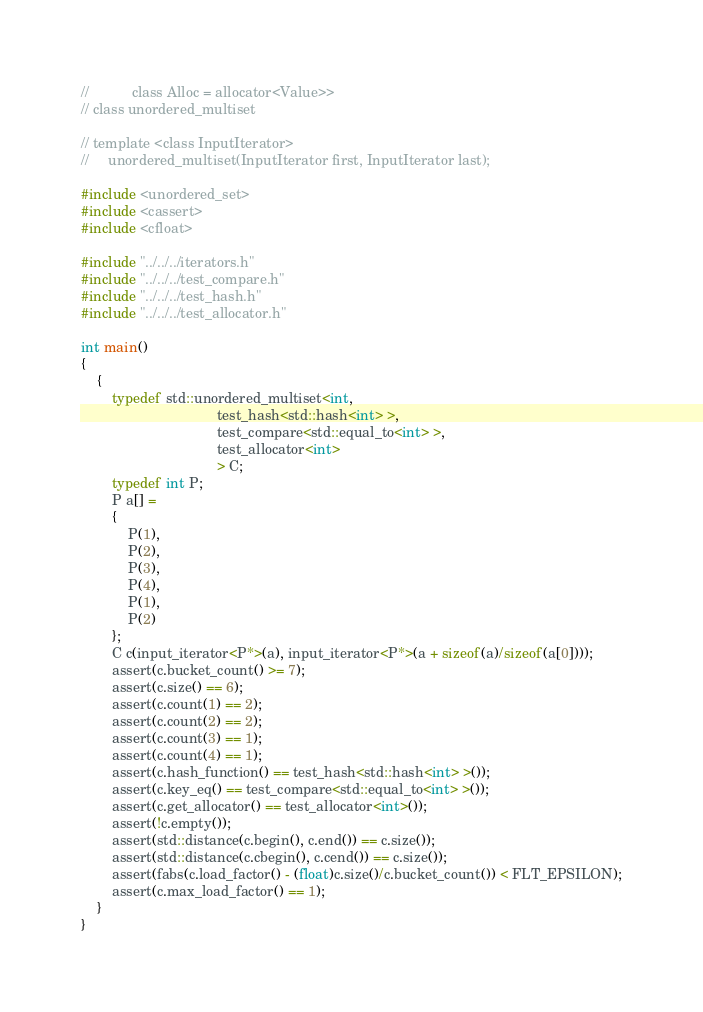Convert code to text. <code><loc_0><loc_0><loc_500><loc_500><_C++_>//           class Alloc = allocator<Value>>
// class unordered_multiset

// template <class InputIterator>
//     unordered_multiset(InputIterator first, InputIterator last);

#include <unordered_set>
#include <cassert>
#include <cfloat>

#include "../../../iterators.h"
#include "../../../test_compare.h"
#include "../../../test_hash.h"
#include "../../../test_allocator.h"

int main()
{
    {
        typedef std::unordered_multiset<int,
                                   test_hash<std::hash<int> >,
                                   test_compare<std::equal_to<int> >,
                                   test_allocator<int>
                                   > C;
        typedef int P;
        P a[] =
        {
            P(1),
            P(2),
            P(3),
            P(4),
            P(1),
            P(2)
        };
        C c(input_iterator<P*>(a), input_iterator<P*>(a + sizeof(a)/sizeof(a[0])));
        assert(c.bucket_count() >= 7);
        assert(c.size() == 6);
        assert(c.count(1) == 2);
        assert(c.count(2) == 2);
        assert(c.count(3) == 1);
        assert(c.count(4) == 1);
        assert(c.hash_function() == test_hash<std::hash<int> >());
        assert(c.key_eq() == test_compare<std::equal_to<int> >());
        assert(c.get_allocator() == test_allocator<int>());
        assert(!c.empty());
        assert(std::distance(c.begin(), c.end()) == c.size());
        assert(std::distance(c.cbegin(), c.cend()) == c.size());
        assert(fabs(c.load_factor() - (float)c.size()/c.bucket_count()) < FLT_EPSILON);
        assert(c.max_load_factor() == 1);
    }
}
</code> 